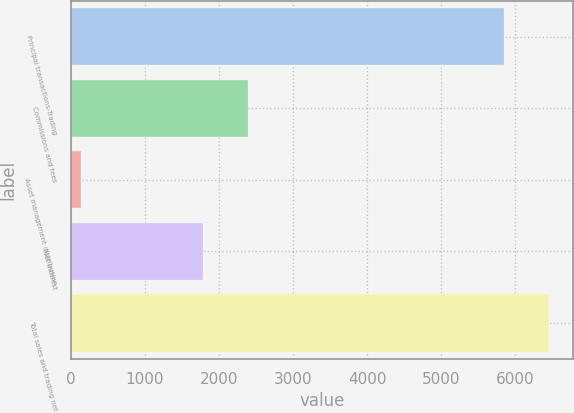Convert chart. <chart><loc_0><loc_0><loc_500><loc_500><bar_chart><fcel>Principal transactions-Trading<fcel>Commissions and fees<fcel>Asset management distribution<fcel>Net interest<fcel>Total sales and trading net<nl><fcel>5853<fcel>2392.6<fcel>144<fcel>1786<fcel>6459.6<nl></chart> 